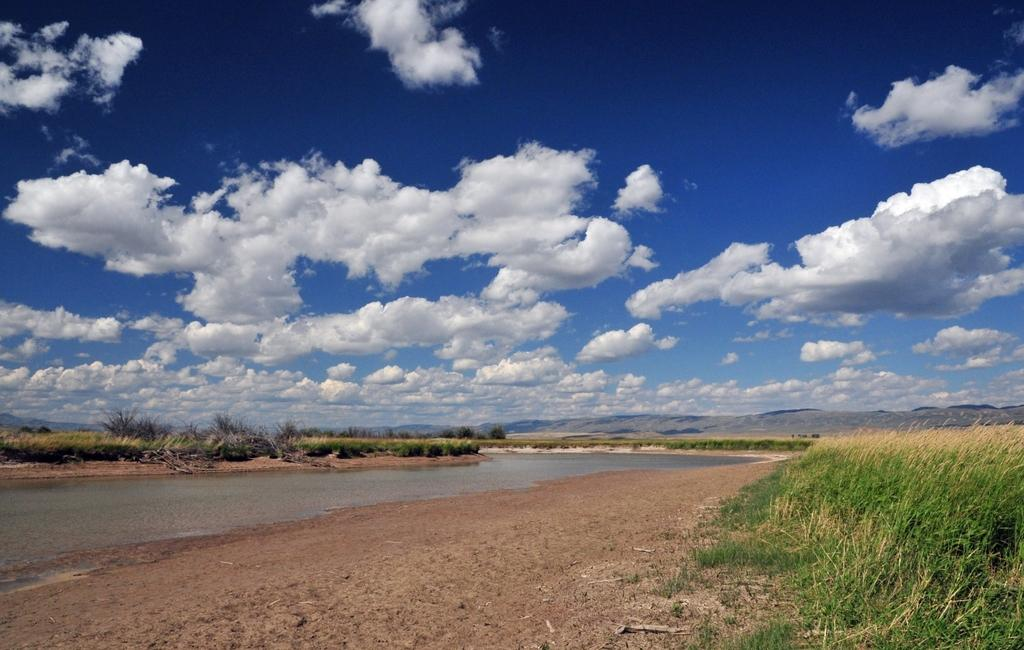What type of natural elements can be seen in the image? There are plants, hills, and a river in the image. Can you describe the sky in the image? There are clouds in the sky in the image. How many cats can be seen playing on the amusement ride in the image? There are no cats or amusement rides present in the image. 